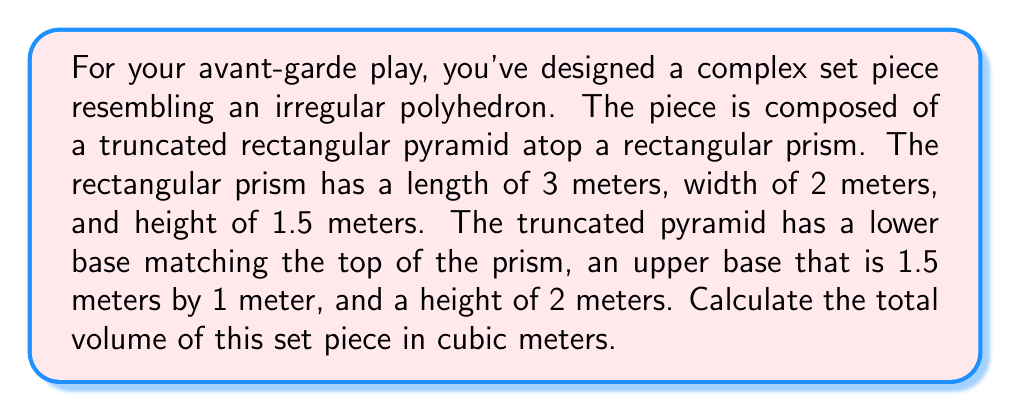Give your solution to this math problem. To solve this problem, we need to calculate the volumes of both parts separately and then add them together.

1. Volume of the rectangular prism:
   $$V_{prism} = l \times w \times h$$
   $$V_{prism} = 3 \times 2 \times 1.5 = 9 \text{ m}^3$$

2. Volume of the truncated pyramid:
   We'll use the formula for the volume of a truncated pyramid:
   $$V_{tpyramid} = \frac{1}{3}h(A_1 + A_2 + \sqrt{A_1A_2})$$
   Where $h$ is the height, $A_1$ is the area of the lower base, and $A_2$ is the area of the upper base.

   Lower base area: $A_1 = 3 \times 2 = 6 \text{ m}^2$
   Upper base area: $A_2 = 1.5 \times 1 = 1.5 \text{ m}^2$

   $$V_{tpyramid} = \frac{1}{3} \times 2(6 + 1.5 + \sqrt{6 \times 1.5})$$
   $$V_{tpyramid} = \frac{2}{3}(7.5 + 3) = \frac{2}{3} \times 10.5 = 7 \text{ m}^3$$

3. Total volume:
   $$V_{total} = V_{prism} + V_{tpyramid}$$
   $$V_{total} = 9 + 7 = 16 \text{ m}^3$$
Answer: 16 m³ 